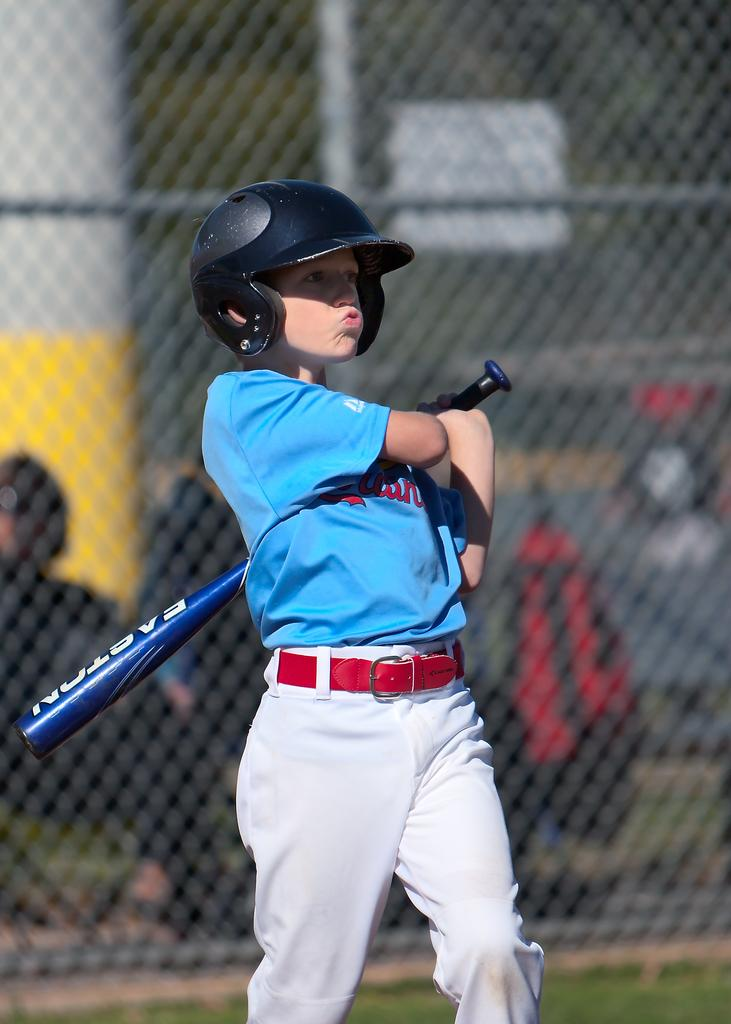Who is the main subject in the image? There is a boy in the image. What is the boy holding in the image? The boy is holding a baseball bat. What is the boy wearing in the image? The boy is wearing a blue and white dress. What can be seen behind the boy in the image? There is a mesh visible behind the boy. What type of attack is the boy planning to execute with the baseball bat in the image? There is no indication in the image that the boy is planning to execute any type of attack with the baseball bat. 